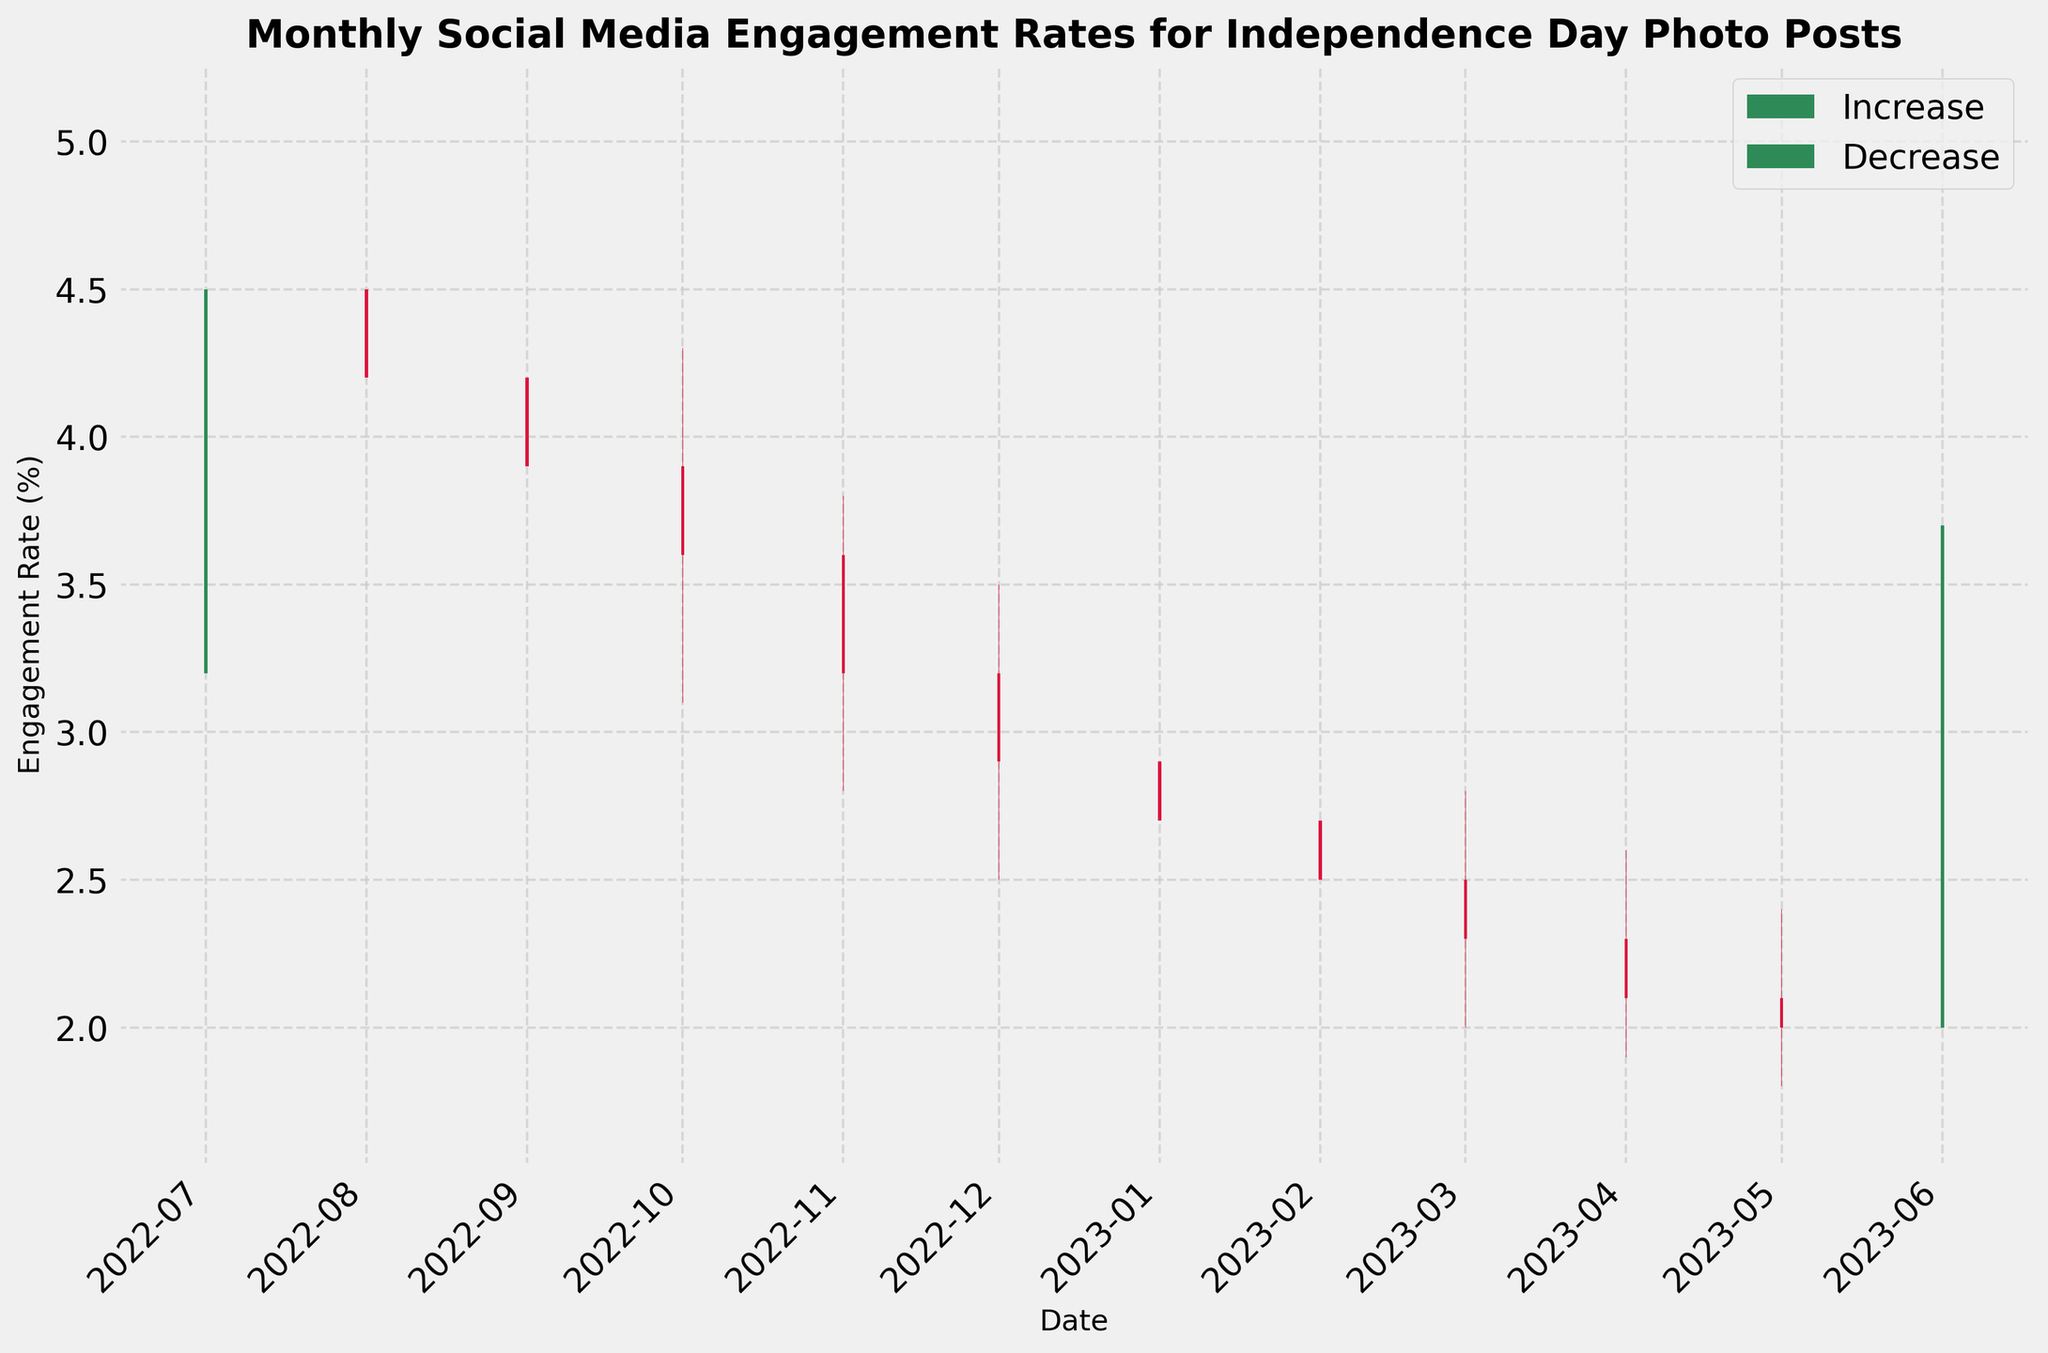What is the title of the chart? The title of the chart is displayed at the top center of the figure.
Answer: Monthly Social Media Engagement Rates for Independence Day Photo Posts What do the green bars represent? The green bars represent months where the engagement rate closed higher than it opened. This indicates an increase in engagement rate for those months.
Answer: Increase in engagement rate How many months show a decrease in engagement rate? To find the number of months with decreasing engagement rates, count the red bars in the plot.
Answer: 9 In which months did the engagement rate increase? Identify the months where the green bars are present, indicating an increase in engagement rate.
Answer: July 2022, June 2023 What was the highest high point observed in the chart? Look for the highest peak among all the bars, both green and red. This is the highest point of engagement rate recorded in the plot.
Answer: 5.1% (August 2022) Which month has the lowest closing engagement rate? Identify the month where the bottom of the last segment of the bar is lowest. This represents the lowest closing engagement rate.
Answer: May 2023 Did the engagement rate close higher or lower in March 2023 compared to January 2023? Compare the closing rates of March and January by checking the bottom of the last segment of each month’s bar.
Answer: Lower What is the range of engagement rates in December 2022? Calculate the range by subtracting the low value from the high value for December 2022.
Answer: 1.0% (Range: 2.5% - 3.5%) Which month showed the highest monthly change in engagement rate? Find the month where the difference between the high and low values is the greatest. This indicates the month with the highest volatility in engagement rates.
Answer: June 2023 How did the engagement rate trend from February 2023 to April 2023? Observe the bars from February to April. Check if the rates consistently increased, decreased, or remained stable.
Answer: Decreasing 